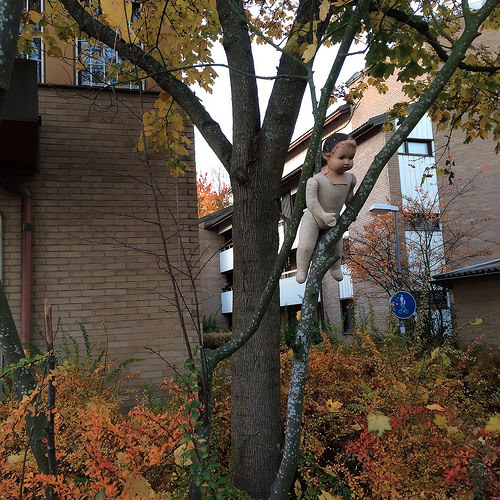<image>
Is the doll on the branch? Yes. Looking at the image, I can see the doll is positioned on top of the branch, with the branch providing support. Is the doll in the tree? No. The doll is not contained within the tree. These objects have a different spatial relationship. 